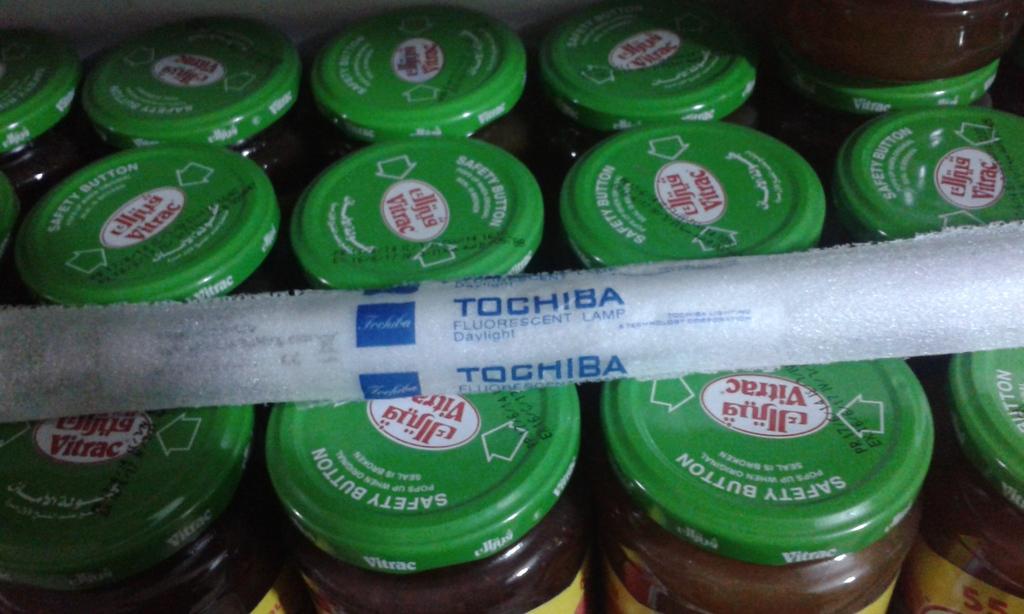What type of button is on the top of the jars?
Offer a very short reply. Safety. 